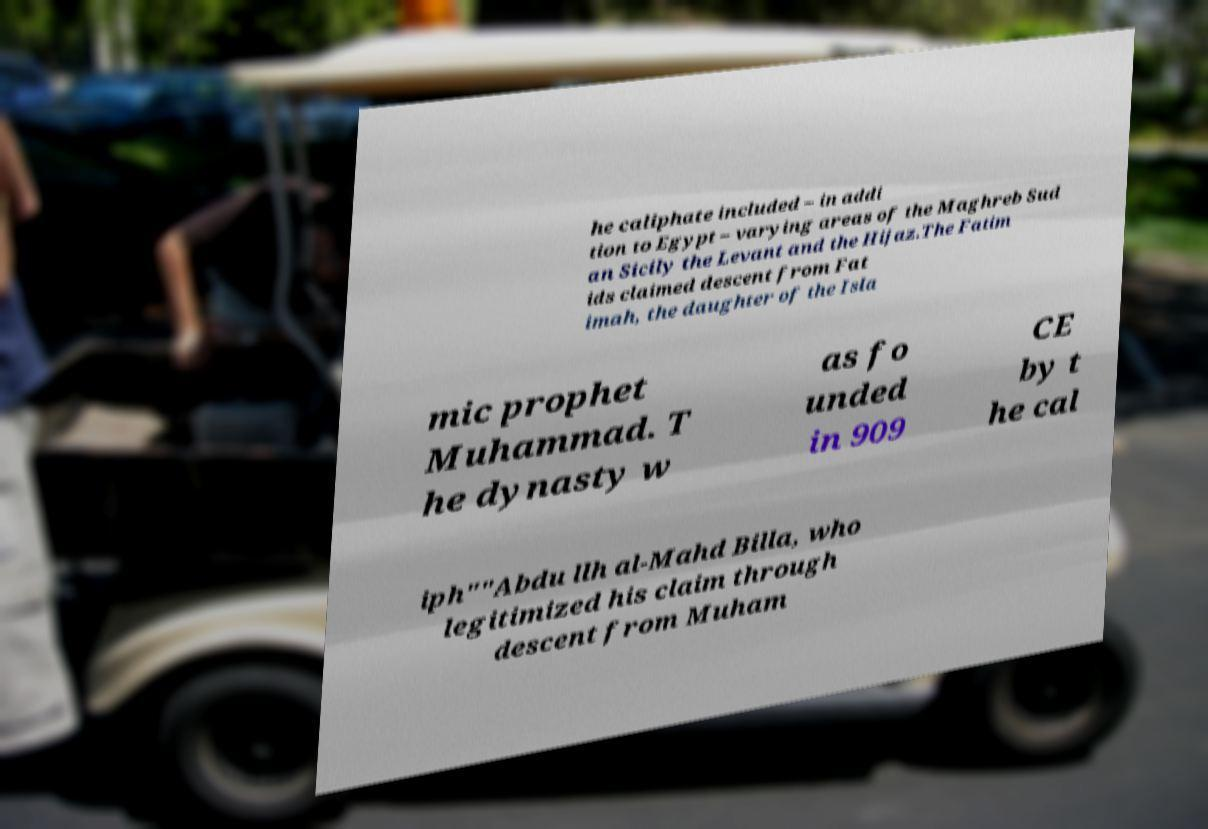For documentation purposes, I need the text within this image transcribed. Could you provide that? he caliphate included – in addi tion to Egypt – varying areas of the Maghreb Sud an Sicily the Levant and the Hijaz.The Fatim ids claimed descent from Fat imah, the daughter of the Isla mic prophet Muhammad. T he dynasty w as fo unded in 909 CE by t he cal iph""Abdu llh al-Mahd Billa, who legitimized his claim through descent from Muham 